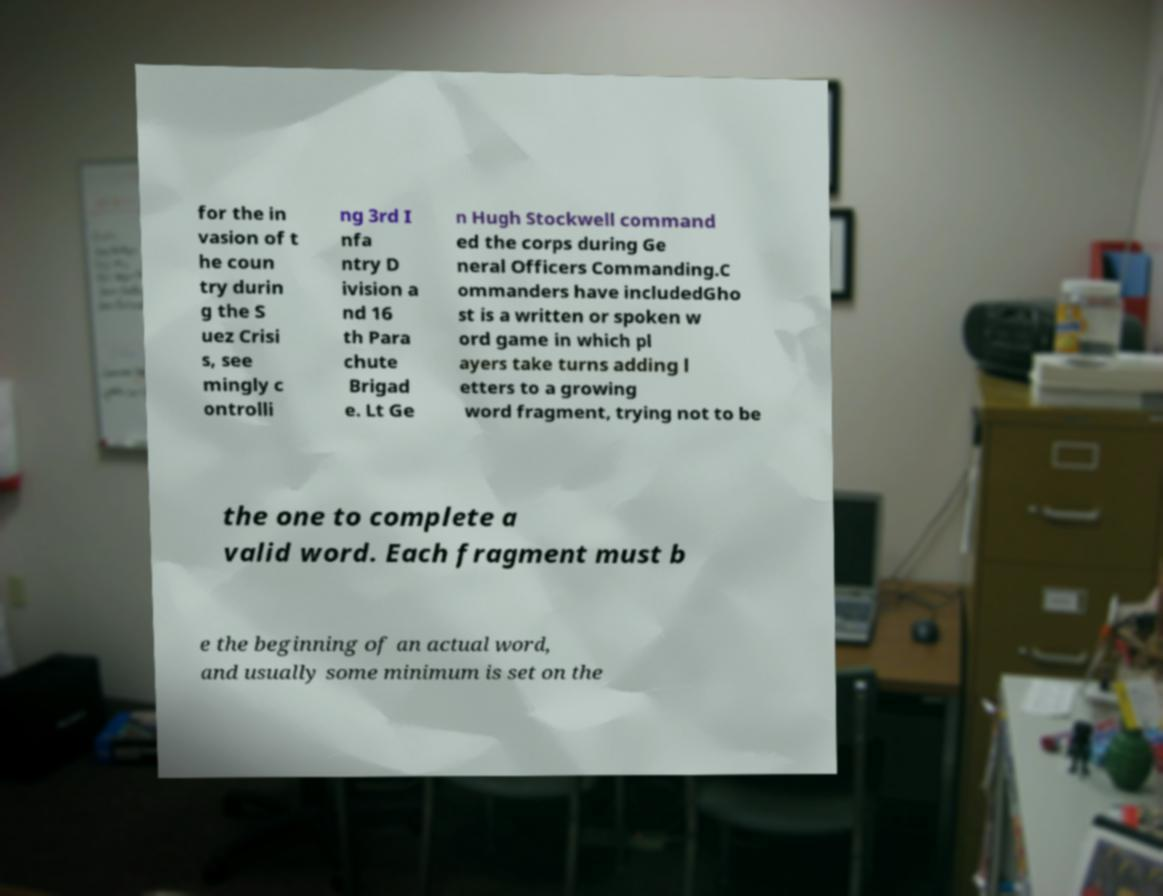Please identify and transcribe the text found in this image. for the in vasion of t he coun try durin g the S uez Crisi s, see mingly c ontrolli ng 3rd I nfa ntry D ivision a nd 16 th Para chute Brigad e. Lt Ge n Hugh Stockwell command ed the corps during Ge neral Officers Commanding.C ommanders have includedGho st is a written or spoken w ord game in which pl ayers take turns adding l etters to a growing word fragment, trying not to be the one to complete a valid word. Each fragment must b e the beginning of an actual word, and usually some minimum is set on the 